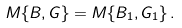<formula> <loc_0><loc_0><loc_500><loc_500>M \{ B , G \} = M \{ B _ { 1 } , G _ { 1 } \} \, .</formula> 